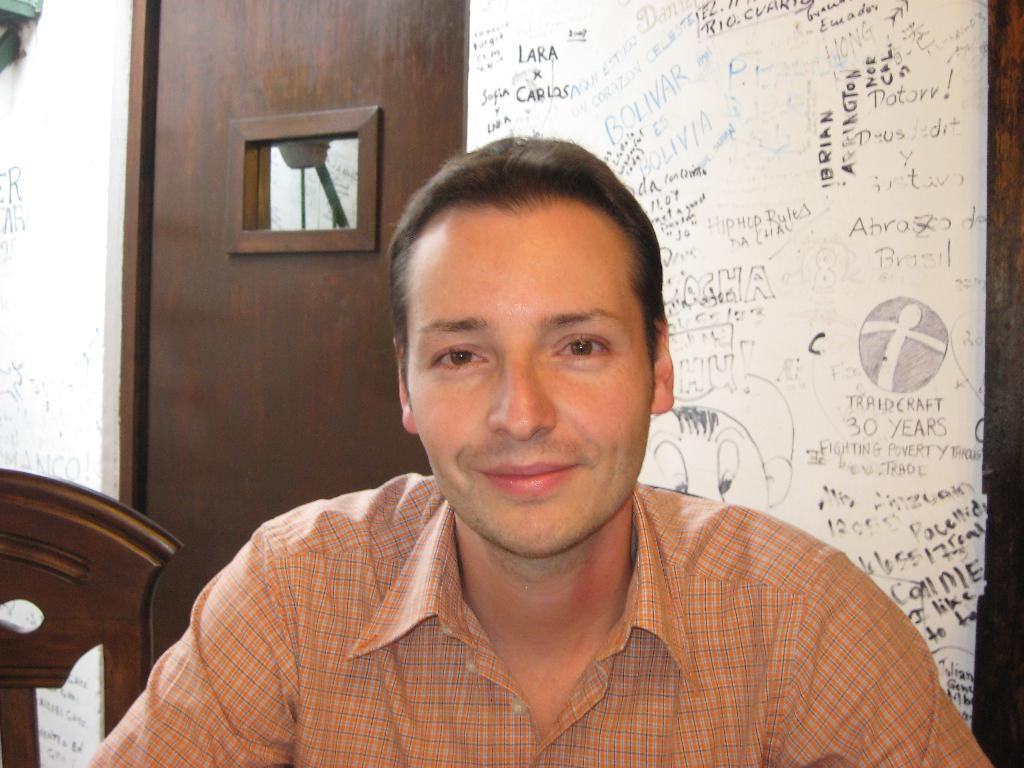Who or what is present in the image? There is a person in the image. What can be seen on the left side of the image? There is an object on the left side of the image. What architectural features are visible in the background of the image? There is a door and a wall in the background of the image. Is there any text or writing visible in the image? Yes, there is something written on the wall in the background of the image. How many lamps are visible in the image? There are no lamps present in the image. Is there a boy interacting with the person in the image? There is no boy present in the image. 